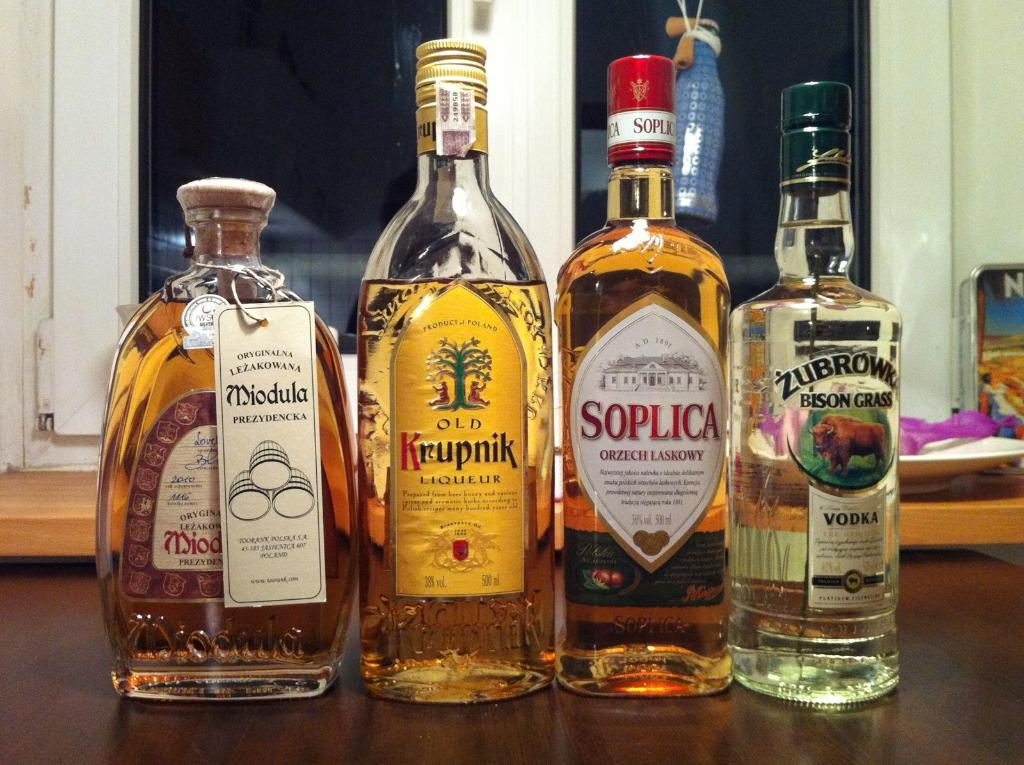<image>
Relay a brief, clear account of the picture shown. Three unopened bottles of liquor are in line, on a counter with an open bottle of Old Krupnik. 